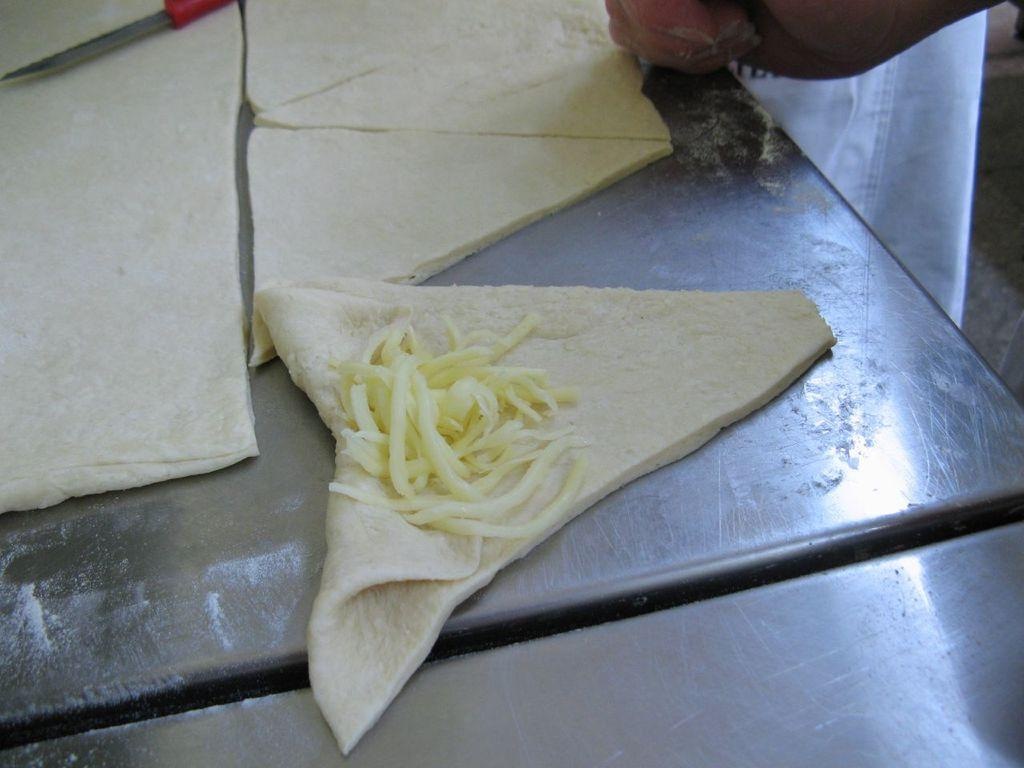What is the food item that has been cut into pieces in the image? The specific food item is not mentioned, but it has been cut into pieces. What can be seen on one of the slices of the cut food item? There is another food item on one of the slices in the image. What tool is used to cut the food item? There is a knife in the image. Whose hand is visible in the image? A person's hand is visible in the image. What type of bottle is being used to cut the food item in the image? There is no bottle present in the image; the food item is being cut with a knife. Is there a beast visible in the image? No, there is no beast present in the image. 